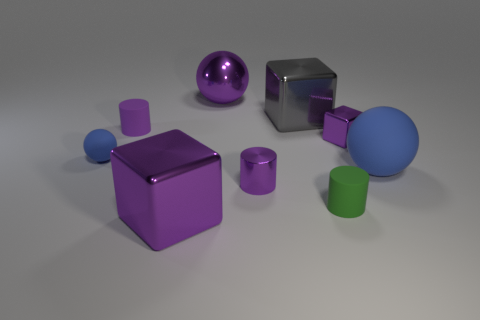What time of day does the lighting in this scene suggest? The lighting in the scene has a soft, diffused quality to it, lacking harsh shadows, which could indicate an overcast day where the sunlight is scattered by the clouds, or an indoor setting illuminated by studio lights designed to mimic such diffusion commonly seen in professional photography settings. 